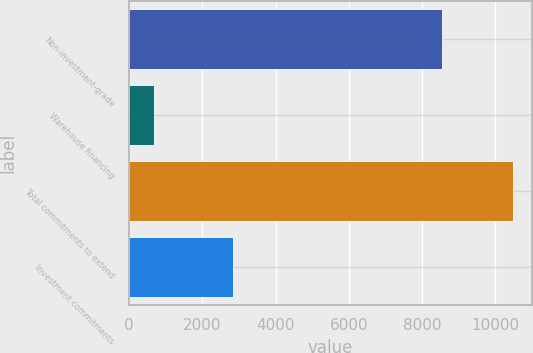<chart> <loc_0><loc_0><loc_500><loc_500><bar_chart><fcel>Non-investment-grade<fcel>Warehouse financing<fcel>Total commitments to extend<fcel>Investment commitments<nl><fcel>8547<fcel>681<fcel>10483<fcel>2835<nl></chart> 